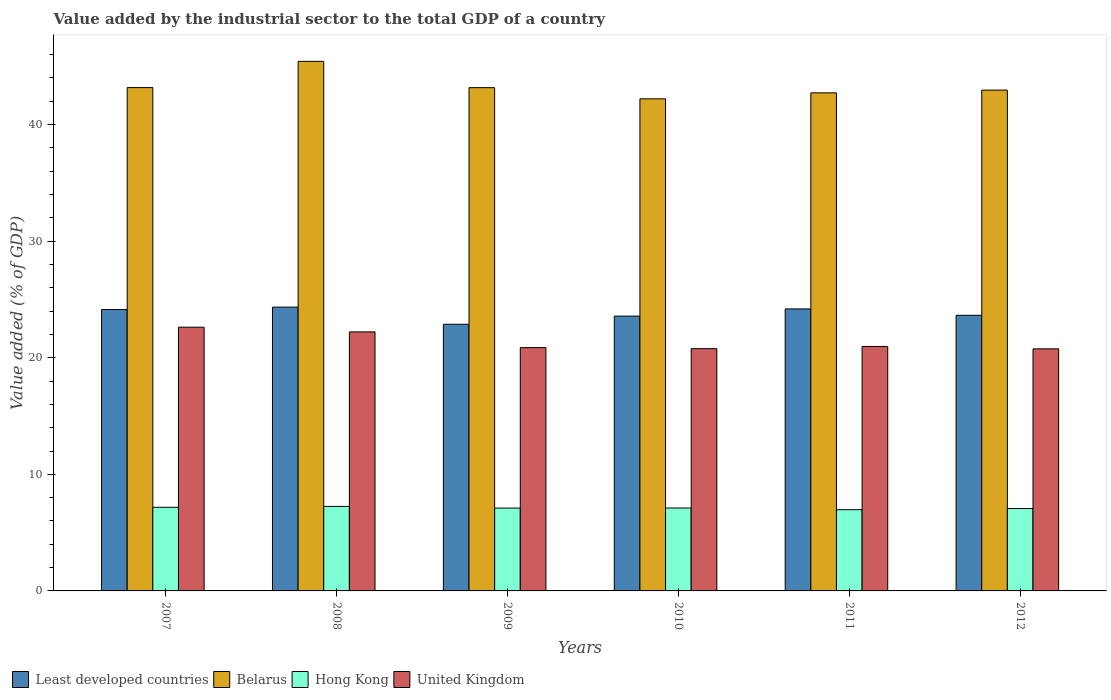Are the number of bars on each tick of the X-axis equal?
Ensure brevity in your answer.  Yes. How many bars are there on the 3rd tick from the left?
Provide a short and direct response. 4. What is the label of the 5th group of bars from the left?
Offer a terse response. 2011. What is the value added by the industrial sector to the total GDP in Belarus in 2011?
Provide a short and direct response. 42.72. Across all years, what is the maximum value added by the industrial sector to the total GDP in Least developed countries?
Your answer should be very brief. 24.34. Across all years, what is the minimum value added by the industrial sector to the total GDP in Least developed countries?
Make the answer very short. 22.87. What is the total value added by the industrial sector to the total GDP in Belarus in the graph?
Offer a terse response. 259.62. What is the difference between the value added by the industrial sector to the total GDP in Least developed countries in 2007 and that in 2008?
Offer a very short reply. -0.2. What is the difference between the value added by the industrial sector to the total GDP in Hong Kong in 2011 and the value added by the industrial sector to the total GDP in Least developed countries in 2012?
Provide a succinct answer. -16.67. What is the average value added by the industrial sector to the total GDP in United Kingdom per year?
Offer a terse response. 21.37. In the year 2008, what is the difference between the value added by the industrial sector to the total GDP in Hong Kong and value added by the industrial sector to the total GDP in Belarus?
Offer a terse response. -38.17. In how many years, is the value added by the industrial sector to the total GDP in Hong Kong greater than 14 %?
Provide a succinct answer. 0. What is the ratio of the value added by the industrial sector to the total GDP in United Kingdom in 2008 to that in 2011?
Provide a short and direct response. 1.06. Is the value added by the industrial sector to the total GDP in Belarus in 2007 less than that in 2011?
Make the answer very short. No. Is the difference between the value added by the industrial sector to the total GDP in Hong Kong in 2008 and 2010 greater than the difference between the value added by the industrial sector to the total GDP in Belarus in 2008 and 2010?
Give a very brief answer. No. What is the difference between the highest and the second highest value added by the industrial sector to the total GDP in Least developed countries?
Give a very brief answer. 0.15. What is the difference between the highest and the lowest value added by the industrial sector to the total GDP in United Kingdom?
Your answer should be compact. 1.86. Is it the case that in every year, the sum of the value added by the industrial sector to the total GDP in Belarus and value added by the industrial sector to the total GDP in Hong Kong is greater than the sum of value added by the industrial sector to the total GDP in United Kingdom and value added by the industrial sector to the total GDP in Least developed countries?
Your answer should be very brief. No. What does the 3rd bar from the right in 2008 represents?
Offer a terse response. Belarus. Is it the case that in every year, the sum of the value added by the industrial sector to the total GDP in United Kingdom and value added by the industrial sector to the total GDP in Belarus is greater than the value added by the industrial sector to the total GDP in Least developed countries?
Your response must be concise. Yes. How many bars are there?
Offer a terse response. 24. How many years are there in the graph?
Ensure brevity in your answer.  6. What is the difference between two consecutive major ticks on the Y-axis?
Keep it short and to the point. 10. Are the values on the major ticks of Y-axis written in scientific E-notation?
Provide a short and direct response. No. Does the graph contain grids?
Your answer should be compact. No. How are the legend labels stacked?
Your response must be concise. Horizontal. What is the title of the graph?
Your response must be concise. Value added by the industrial sector to the total GDP of a country. Does "Libya" appear as one of the legend labels in the graph?
Provide a short and direct response. No. What is the label or title of the Y-axis?
Your answer should be compact. Value added (% of GDP). What is the Value added (% of GDP) in Least developed countries in 2007?
Give a very brief answer. 24.14. What is the Value added (% of GDP) of Belarus in 2007?
Your answer should be very brief. 43.17. What is the Value added (% of GDP) in Hong Kong in 2007?
Ensure brevity in your answer.  7.17. What is the Value added (% of GDP) in United Kingdom in 2007?
Your answer should be compact. 22.62. What is the Value added (% of GDP) in Least developed countries in 2008?
Give a very brief answer. 24.34. What is the Value added (% of GDP) of Belarus in 2008?
Ensure brevity in your answer.  45.42. What is the Value added (% of GDP) in Hong Kong in 2008?
Give a very brief answer. 7.25. What is the Value added (% of GDP) in United Kingdom in 2008?
Keep it short and to the point. 22.22. What is the Value added (% of GDP) in Least developed countries in 2009?
Offer a terse response. 22.87. What is the Value added (% of GDP) of Belarus in 2009?
Offer a very short reply. 43.16. What is the Value added (% of GDP) of Hong Kong in 2009?
Give a very brief answer. 7.11. What is the Value added (% of GDP) of United Kingdom in 2009?
Make the answer very short. 20.87. What is the Value added (% of GDP) of Least developed countries in 2010?
Offer a very short reply. 23.57. What is the Value added (% of GDP) of Belarus in 2010?
Give a very brief answer. 42.21. What is the Value added (% of GDP) in Hong Kong in 2010?
Keep it short and to the point. 7.11. What is the Value added (% of GDP) in United Kingdom in 2010?
Offer a terse response. 20.78. What is the Value added (% of GDP) in Least developed countries in 2011?
Provide a succinct answer. 24.18. What is the Value added (% of GDP) of Belarus in 2011?
Keep it short and to the point. 42.72. What is the Value added (% of GDP) of Hong Kong in 2011?
Your answer should be compact. 6.97. What is the Value added (% of GDP) in United Kingdom in 2011?
Offer a terse response. 20.97. What is the Value added (% of GDP) of Least developed countries in 2012?
Your answer should be compact. 23.64. What is the Value added (% of GDP) of Belarus in 2012?
Give a very brief answer. 42.95. What is the Value added (% of GDP) in Hong Kong in 2012?
Provide a short and direct response. 7.07. What is the Value added (% of GDP) in United Kingdom in 2012?
Your answer should be compact. 20.76. Across all years, what is the maximum Value added (% of GDP) of Least developed countries?
Your response must be concise. 24.34. Across all years, what is the maximum Value added (% of GDP) in Belarus?
Keep it short and to the point. 45.42. Across all years, what is the maximum Value added (% of GDP) in Hong Kong?
Ensure brevity in your answer.  7.25. Across all years, what is the maximum Value added (% of GDP) of United Kingdom?
Ensure brevity in your answer.  22.62. Across all years, what is the minimum Value added (% of GDP) of Least developed countries?
Give a very brief answer. 22.87. Across all years, what is the minimum Value added (% of GDP) in Belarus?
Keep it short and to the point. 42.21. Across all years, what is the minimum Value added (% of GDP) of Hong Kong?
Give a very brief answer. 6.97. Across all years, what is the minimum Value added (% of GDP) in United Kingdom?
Your answer should be compact. 20.76. What is the total Value added (% of GDP) in Least developed countries in the graph?
Make the answer very short. 142.74. What is the total Value added (% of GDP) in Belarus in the graph?
Your answer should be compact. 259.62. What is the total Value added (% of GDP) of Hong Kong in the graph?
Your answer should be compact. 42.67. What is the total Value added (% of GDP) of United Kingdom in the graph?
Your answer should be compact. 128.21. What is the difference between the Value added (% of GDP) of Least developed countries in 2007 and that in 2008?
Give a very brief answer. -0.2. What is the difference between the Value added (% of GDP) of Belarus in 2007 and that in 2008?
Your answer should be compact. -2.25. What is the difference between the Value added (% of GDP) in Hong Kong in 2007 and that in 2008?
Your response must be concise. -0.08. What is the difference between the Value added (% of GDP) of United Kingdom in 2007 and that in 2008?
Your answer should be very brief. 0.4. What is the difference between the Value added (% of GDP) of Least developed countries in 2007 and that in 2009?
Your response must be concise. 1.27. What is the difference between the Value added (% of GDP) of Belarus in 2007 and that in 2009?
Provide a succinct answer. 0.01. What is the difference between the Value added (% of GDP) of Hong Kong in 2007 and that in 2009?
Make the answer very short. 0.07. What is the difference between the Value added (% of GDP) of United Kingdom in 2007 and that in 2009?
Offer a terse response. 1.75. What is the difference between the Value added (% of GDP) in Least developed countries in 2007 and that in 2010?
Offer a terse response. 0.57. What is the difference between the Value added (% of GDP) of Belarus in 2007 and that in 2010?
Offer a very short reply. 0.96. What is the difference between the Value added (% of GDP) in Hong Kong in 2007 and that in 2010?
Your response must be concise. 0.06. What is the difference between the Value added (% of GDP) of United Kingdom in 2007 and that in 2010?
Offer a very short reply. 1.84. What is the difference between the Value added (% of GDP) of Least developed countries in 2007 and that in 2011?
Provide a short and direct response. -0.05. What is the difference between the Value added (% of GDP) in Belarus in 2007 and that in 2011?
Keep it short and to the point. 0.45. What is the difference between the Value added (% of GDP) of Hong Kong in 2007 and that in 2011?
Offer a very short reply. 0.2. What is the difference between the Value added (% of GDP) in United Kingdom in 2007 and that in 2011?
Keep it short and to the point. 1.65. What is the difference between the Value added (% of GDP) in Least developed countries in 2007 and that in 2012?
Provide a succinct answer. 0.5. What is the difference between the Value added (% of GDP) of Belarus in 2007 and that in 2012?
Offer a very short reply. 0.22. What is the difference between the Value added (% of GDP) in Hong Kong in 2007 and that in 2012?
Offer a terse response. 0.11. What is the difference between the Value added (% of GDP) in United Kingdom in 2007 and that in 2012?
Keep it short and to the point. 1.86. What is the difference between the Value added (% of GDP) of Least developed countries in 2008 and that in 2009?
Offer a very short reply. 1.47. What is the difference between the Value added (% of GDP) in Belarus in 2008 and that in 2009?
Make the answer very short. 2.26. What is the difference between the Value added (% of GDP) of Hong Kong in 2008 and that in 2009?
Keep it short and to the point. 0.14. What is the difference between the Value added (% of GDP) in United Kingdom in 2008 and that in 2009?
Provide a succinct answer. 1.35. What is the difference between the Value added (% of GDP) in Least developed countries in 2008 and that in 2010?
Your answer should be compact. 0.77. What is the difference between the Value added (% of GDP) of Belarus in 2008 and that in 2010?
Ensure brevity in your answer.  3.21. What is the difference between the Value added (% of GDP) of Hong Kong in 2008 and that in 2010?
Give a very brief answer. 0.14. What is the difference between the Value added (% of GDP) of United Kingdom in 2008 and that in 2010?
Offer a very short reply. 1.44. What is the difference between the Value added (% of GDP) in Least developed countries in 2008 and that in 2011?
Provide a short and direct response. 0.15. What is the difference between the Value added (% of GDP) in Belarus in 2008 and that in 2011?
Make the answer very short. 2.7. What is the difference between the Value added (% of GDP) of Hong Kong in 2008 and that in 2011?
Provide a succinct answer. 0.28. What is the difference between the Value added (% of GDP) in United Kingdom in 2008 and that in 2011?
Your answer should be very brief. 1.25. What is the difference between the Value added (% of GDP) of Least developed countries in 2008 and that in 2012?
Provide a succinct answer. 0.7. What is the difference between the Value added (% of GDP) of Belarus in 2008 and that in 2012?
Provide a succinct answer. 2.47. What is the difference between the Value added (% of GDP) of Hong Kong in 2008 and that in 2012?
Provide a short and direct response. 0.18. What is the difference between the Value added (% of GDP) in United Kingdom in 2008 and that in 2012?
Provide a succinct answer. 1.45. What is the difference between the Value added (% of GDP) in Least developed countries in 2009 and that in 2010?
Your answer should be very brief. -0.7. What is the difference between the Value added (% of GDP) in Belarus in 2009 and that in 2010?
Offer a terse response. 0.96. What is the difference between the Value added (% of GDP) of Hong Kong in 2009 and that in 2010?
Make the answer very short. -0.01. What is the difference between the Value added (% of GDP) in United Kingdom in 2009 and that in 2010?
Give a very brief answer. 0.09. What is the difference between the Value added (% of GDP) of Least developed countries in 2009 and that in 2011?
Make the answer very short. -1.31. What is the difference between the Value added (% of GDP) in Belarus in 2009 and that in 2011?
Your answer should be compact. 0.44. What is the difference between the Value added (% of GDP) in Hong Kong in 2009 and that in 2011?
Offer a terse response. 0.14. What is the difference between the Value added (% of GDP) of United Kingdom in 2009 and that in 2011?
Your answer should be compact. -0.1. What is the difference between the Value added (% of GDP) of Least developed countries in 2009 and that in 2012?
Ensure brevity in your answer.  -0.77. What is the difference between the Value added (% of GDP) of Belarus in 2009 and that in 2012?
Give a very brief answer. 0.21. What is the difference between the Value added (% of GDP) in Hong Kong in 2009 and that in 2012?
Your answer should be very brief. 0.04. What is the difference between the Value added (% of GDP) in United Kingdom in 2009 and that in 2012?
Your answer should be very brief. 0.11. What is the difference between the Value added (% of GDP) in Least developed countries in 2010 and that in 2011?
Give a very brief answer. -0.61. What is the difference between the Value added (% of GDP) in Belarus in 2010 and that in 2011?
Keep it short and to the point. -0.51. What is the difference between the Value added (% of GDP) in Hong Kong in 2010 and that in 2011?
Give a very brief answer. 0.14. What is the difference between the Value added (% of GDP) in United Kingdom in 2010 and that in 2011?
Ensure brevity in your answer.  -0.19. What is the difference between the Value added (% of GDP) of Least developed countries in 2010 and that in 2012?
Offer a terse response. -0.07. What is the difference between the Value added (% of GDP) in Belarus in 2010 and that in 2012?
Keep it short and to the point. -0.75. What is the difference between the Value added (% of GDP) in Hong Kong in 2010 and that in 2012?
Provide a succinct answer. 0.05. What is the difference between the Value added (% of GDP) in United Kingdom in 2010 and that in 2012?
Give a very brief answer. 0.02. What is the difference between the Value added (% of GDP) in Least developed countries in 2011 and that in 2012?
Make the answer very short. 0.54. What is the difference between the Value added (% of GDP) of Belarus in 2011 and that in 2012?
Offer a very short reply. -0.23. What is the difference between the Value added (% of GDP) in Hong Kong in 2011 and that in 2012?
Keep it short and to the point. -0.1. What is the difference between the Value added (% of GDP) in United Kingdom in 2011 and that in 2012?
Your answer should be compact. 0.21. What is the difference between the Value added (% of GDP) of Least developed countries in 2007 and the Value added (% of GDP) of Belarus in 2008?
Your answer should be compact. -21.28. What is the difference between the Value added (% of GDP) of Least developed countries in 2007 and the Value added (% of GDP) of Hong Kong in 2008?
Keep it short and to the point. 16.89. What is the difference between the Value added (% of GDP) in Least developed countries in 2007 and the Value added (% of GDP) in United Kingdom in 2008?
Ensure brevity in your answer.  1.92. What is the difference between the Value added (% of GDP) of Belarus in 2007 and the Value added (% of GDP) of Hong Kong in 2008?
Your answer should be compact. 35.92. What is the difference between the Value added (% of GDP) of Belarus in 2007 and the Value added (% of GDP) of United Kingdom in 2008?
Your answer should be very brief. 20.95. What is the difference between the Value added (% of GDP) in Hong Kong in 2007 and the Value added (% of GDP) in United Kingdom in 2008?
Provide a short and direct response. -15.04. What is the difference between the Value added (% of GDP) of Least developed countries in 2007 and the Value added (% of GDP) of Belarus in 2009?
Offer a very short reply. -19.03. What is the difference between the Value added (% of GDP) in Least developed countries in 2007 and the Value added (% of GDP) in Hong Kong in 2009?
Offer a very short reply. 17.03. What is the difference between the Value added (% of GDP) of Least developed countries in 2007 and the Value added (% of GDP) of United Kingdom in 2009?
Keep it short and to the point. 3.27. What is the difference between the Value added (% of GDP) in Belarus in 2007 and the Value added (% of GDP) in Hong Kong in 2009?
Provide a succinct answer. 36.06. What is the difference between the Value added (% of GDP) of Belarus in 2007 and the Value added (% of GDP) of United Kingdom in 2009?
Keep it short and to the point. 22.3. What is the difference between the Value added (% of GDP) of Hong Kong in 2007 and the Value added (% of GDP) of United Kingdom in 2009?
Ensure brevity in your answer.  -13.69. What is the difference between the Value added (% of GDP) in Least developed countries in 2007 and the Value added (% of GDP) in Belarus in 2010?
Your response must be concise. -18.07. What is the difference between the Value added (% of GDP) of Least developed countries in 2007 and the Value added (% of GDP) of Hong Kong in 2010?
Ensure brevity in your answer.  17.02. What is the difference between the Value added (% of GDP) in Least developed countries in 2007 and the Value added (% of GDP) in United Kingdom in 2010?
Make the answer very short. 3.36. What is the difference between the Value added (% of GDP) of Belarus in 2007 and the Value added (% of GDP) of Hong Kong in 2010?
Your response must be concise. 36.06. What is the difference between the Value added (% of GDP) in Belarus in 2007 and the Value added (% of GDP) in United Kingdom in 2010?
Provide a succinct answer. 22.39. What is the difference between the Value added (% of GDP) of Hong Kong in 2007 and the Value added (% of GDP) of United Kingdom in 2010?
Keep it short and to the point. -13.61. What is the difference between the Value added (% of GDP) in Least developed countries in 2007 and the Value added (% of GDP) in Belarus in 2011?
Your response must be concise. -18.58. What is the difference between the Value added (% of GDP) of Least developed countries in 2007 and the Value added (% of GDP) of Hong Kong in 2011?
Your answer should be compact. 17.17. What is the difference between the Value added (% of GDP) of Least developed countries in 2007 and the Value added (% of GDP) of United Kingdom in 2011?
Your answer should be very brief. 3.17. What is the difference between the Value added (% of GDP) of Belarus in 2007 and the Value added (% of GDP) of Hong Kong in 2011?
Provide a succinct answer. 36.2. What is the difference between the Value added (% of GDP) in Belarus in 2007 and the Value added (% of GDP) in United Kingdom in 2011?
Provide a succinct answer. 22.2. What is the difference between the Value added (% of GDP) of Hong Kong in 2007 and the Value added (% of GDP) of United Kingdom in 2011?
Provide a short and direct response. -13.8. What is the difference between the Value added (% of GDP) of Least developed countries in 2007 and the Value added (% of GDP) of Belarus in 2012?
Keep it short and to the point. -18.82. What is the difference between the Value added (% of GDP) of Least developed countries in 2007 and the Value added (% of GDP) of Hong Kong in 2012?
Provide a succinct answer. 17.07. What is the difference between the Value added (% of GDP) of Least developed countries in 2007 and the Value added (% of GDP) of United Kingdom in 2012?
Your response must be concise. 3.37. What is the difference between the Value added (% of GDP) in Belarus in 2007 and the Value added (% of GDP) in Hong Kong in 2012?
Ensure brevity in your answer.  36.1. What is the difference between the Value added (% of GDP) of Belarus in 2007 and the Value added (% of GDP) of United Kingdom in 2012?
Your response must be concise. 22.41. What is the difference between the Value added (% of GDP) in Hong Kong in 2007 and the Value added (% of GDP) in United Kingdom in 2012?
Provide a short and direct response. -13.59. What is the difference between the Value added (% of GDP) of Least developed countries in 2008 and the Value added (% of GDP) of Belarus in 2009?
Ensure brevity in your answer.  -18.82. What is the difference between the Value added (% of GDP) of Least developed countries in 2008 and the Value added (% of GDP) of Hong Kong in 2009?
Make the answer very short. 17.23. What is the difference between the Value added (% of GDP) of Least developed countries in 2008 and the Value added (% of GDP) of United Kingdom in 2009?
Offer a very short reply. 3.47. What is the difference between the Value added (% of GDP) of Belarus in 2008 and the Value added (% of GDP) of Hong Kong in 2009?
Ensure brevity in your answer.  38.31. What is the difference between the Value added (% of GDP) in Belarus in 2008 and the Value added (% of GDP) in United Kingdom in 2009?
Give a very brief answer. 24.55. What is the difference between the Value added (% of GDP) of Hong Kong in 2008 and the Value added (% of GDP) of United Kingdom in 2009?
Your response must be concise. -13.62. What is the difference between the Value added (% of GDP) of Least developed countries in 2008 and the Value added (% of GDP) of Belarus in 2010?
Your answer should be compact. -17.87. What is the difference between the Value added (% of GDP) of Least developed countries in 2008 and the Value added (% of GDP) of Hong Kong in 2010?
Provide a succinct answer. 17.23. What is the difference between the Value added (% of GDP) in Least developed countries in 2008 and the Value added (% of GDP) in United Kingdom in 2010?
Provide a succinct answer. 3.56. What is the difference between the Value added (% of GDP) of Belarus in 2008 and the Value added (% of GDP) of Hong Kong in 2010?
Make the answer very short. 38.31. What is the difference between the Value added (% of GDP) of Belarus in 2008 and the Value added (% of GDP) of United Kingdom in 2010?
Give a very brief answer. 24.64. What is the difference between the Value added (% of GDP) in Hong Kong in 2008 and the Value added (% of GDP) in United Kingdom in 2010?
Your response must be concise. -13.53. What is the difference between the Value added (% of GDP) of Least developed countries in 2008 and the Value added (% of GDP) of Belarus in 2011?
Give a very brief answer. -18.38. What is the difference between the Value added (% of GDP) of Least developed countries in 2008 and the Value added (% of GDP) of Hong Kong in 2011?
Provide a short and direct response. 17.37. What is the difference between the Value added (% of GDP) in Least developed countries in 2008 and the Value added (% of GDP) in United Kingdom in 2011?
Give a very brief answer. 3.37. What is the difference between the Value added (% of GDP) in Belarus in 2008 and the Value added (% of GDP) in Hong Kong in 2011?
Ensure brevity in your answer.  38.45. What is the difference between the Value added (% of GDP) of Belarus in 2008 and the Value added (% of GDP) of United Kingdom in 2011?
Keep it short and to the point. 24.45. What is the difference between the Value added (% of GDP) of Hong Kong in 2008 and the Value added (% of GDP) of United Kingdom in 2011?
Give a very brief answer. -13.72. What is the difference between the Value added (% of GDP) of Least developed countries in 2008 and the Value added (% of GDP) of Belarus in 2012?
Offer a very short reply. -18.61. What is the difference between the Value added (% of GDP) of Least developed countries in 2008 and the Value added (% of GDP) of Hong Kong in 2012?
Your answer should be very brief. 17.27. What is the difference between the Value added (% of GDP) in Least developed countries in 2008 and the Value added (% of GDP) in United Kingdom in 2012?
Make the answer very short. 3.58. What is the difference between the Value added (% of GDP) in Belarus in 2008 and the Value added (% of GDP) in Hong Kong in 2012?
Make the answer very short. 38.35. What is the difference between the Value added (% of GDP) of Belarus in 2008 and the Value added (% of GDP) of United Kingdom in 2012?
Keep it short and to the point. 24.66. What is the difference between the Value added (% of GDP) in Hong Kong in 2008 and the Value added (% of GDP) in United Kingdom in 2012?
Provide a succinct answer. -13.51. What is the difference between the Value added (% of GDP) in Least developed countries in 2009 and the Value added (% of GDP) in Belarus in 2010?
Keep it short and to the point. -19.34. What is the difference between the Value added (% of GDP) of Least developed countries in 2009 and the Value added (% of GDP) of Hong Kong in 2010?
Your answer should be very brief. 15.76. What is the difference between the Value added (% of GDP) of Least developed countries in 2009 and the Value added (% of GDP) of United Kingdom in 2010?
Give a very brief answer. 2.09. What is the difference between the Value added (% of GDP) in Belarus in 2009 and the Value added (% of GDP) in Hong Kong in 2010?
Keep it short and to the point. 36.05. What is the difference between the Value added (% of GDP) of Belarus in 2009 and the Value added (% of GDP) of United Kingdom in 2010?
Your answer should be very brief. 22.38. What is the difference between the Value added (% of GDP) of Hong Kong in 2009 and the Value added (% of GDP) of United Kingdom in 2010?
Your answer should be compact. -13.67. What is the difference between the Value added (% of GDP) of Least developed countries in 2009 and the Value added (% of GDP) of Belarus in 2011?
Make the answer very short. -19.85. What is the difference between the Value added (% of GDP) in Least developed countries in 2009 and the Value added (% of GDP) in Hong Kong in 2011?
Your response must be concise. 15.9. What is the difference between the Value added (% of GDP) in Least developed countries in 2009 and the Value added (% of GDP) in United Kingdom in 2011?
Your answer should be compact. 1.9. What is the difference between the Value added (% of GDP) in Belarus in 2009 and the Value added (% of GDP) in Hong Kong in 2011?
Ensure brevity in your answer.  36.19. What is the difference between the Value added (% of GDP) of Belarus in 2009 and the Value added (% of GDP) of United Kingdom in 2011?
Ensure brevity in your answer.  22.19. What is the difference between the Value added (% of GDP) of Hong Kong in 2009 and the Value added (% of GDP) of United Kingdom in 2011?
Make the answer very short. -13.86. What is the difference between the Value added (% of GDP) of Least developed countries in 2009 and the Value added (% of GDP) of Belarus in 2012?
Your answer should be compact. -20.08. What is the difference between the Value added (% of GDP) of Least developed countries in 2009 and the Value added (% of GDP) of Hong Kong in 2012?
Your answer should be compact. 15.8. What is the difference between the Value added (% of GDP) in Least developed countries in 2009 and the Value added (% of GDP) in United Kingdom in 2012?
Keep it short and to the point. 2.11. What is the difference between the Value added (% of GDP) of Belarus in 2009 and the Value added (% of GDP) of Hong Kong in 2012?
Offer a very short reply. 36.1. What is the difference between the Value added (% of GDP) in Belarus in 2009 and the Value added (% of GDP) in United Kingdom in 2012?
Your answer should be very brief. 22.4. What is the difference between the Value added (% of GDP) of Hong Kong in 2009 and the Value added (% of GDP) of United Kingdom in 2012?
Give a very brief answer. -13.66. What is the difference between the Value added (% of GDP) of Least developed countries in 2010 and the Value added (% of GDP) of Belarus in 2011?
Provide a short and direct response. -19.15. What is the difference between the Value added (% of GDP) in Least developed countries in 2010 and the Value added (% of GDP) in Hong Kong in 2011?
Ensure brevity in your answer.  16.6. What is the difference between the Value added (% of GDP) of Least developed countries in 2010 and the Value added (% of GDP) of United Kingdom in 2011?
Your answer should be compact. 2.6. What is the difference between the Value added (% of GDP) of Belarus in 2010 and the Value added (% of GDP) of Hong Kong in 2011?
Offer a very short reply. 35.24. What is the difference between the Value added (% of GDP) of Belarus in 2010 and the Value added (% of GDP) of United Kingdom in 2011?
Ensure brevity in your answer.  21.24. What is the difference between the Value added (% of GDP) in Hong Kong in 2010 and the Value added (% of GDP) in United Kingdom in 2011?
Ensure brevity in your answer.  -13.86. What is the difference between the Value added (% of GDP) of Least developed countries in 2010 and the Value added (% of GDP) of Belarus in 2012?
Give a very brief answer. -19.38. What is the difference between the Value added (% of GDP) in Least developed countries in 2010 and the Value added (% of GDP) in Hong Kong in 2012?
Your answer should be very brief. 16.5. What is the difference between the Value added (% of GDP) in Least developed countries in 2010 and the Value added (% of GDP) in United Kingdom in 2012?
Keep it short and to the point. 2.81. What is the difference between the Value added (% of GDP) in Belarus in 2010 and the Value added (% of GDP) in Hong Kong in 2012?
Keep it short and to the point. 35.14. What is the difference between the Value added (% of GDP) in Belarus in 2010 and the Value added (% of GDP) in United Kingdom in 2012?
Your answer should be very brief. 21.44. What is the difference between the Value added (% of GDP) of Hong Kong in 2010 and the Value added (% of GDP) of United Kingdom in 2012?
Provide a short and direct response. -13.65. What is the difference between the Value added (% of GDP) in Least developed countries in 2011 and the Value added (% of GDP) in Belarus in 2012?
Offer a very short reply. -18.77. What is the difference between the Value added (% of GDP) of Least developed countries in 2011 and the Value added (% of GDP) of Hong Kong in 2012?
Your answer should be very brief. 17.12. What is the difference between the Value added (% of GDP) of Least developed countries in 2011 and the Value added (% of GDP) of United Kingdom in 2012?
Your answer should be compact. 3.42. What is the difference between the Value added (% of GDP) of Belarus in 2011 and the Value added (% of GDP) of Hong Kong in 2012?
Give a very brief answer. 35.65. What is the difference between the Value added (% of GDP) in Belarus in 2011 and the Value added (% of GDP) in United Kingdom in 2012?
Give a very brief answer. 21.96. What is the difference between the Value added (% of GDP) in Hong Kong in 2011 and the Value added (% of GDP) in United Kingdom in 2012?
Provide a succinct answer. -13.79. What is the average Value added (% of GDP) of Least developed countries per year?
Provide a short and direct response. 23.79. What is the average Value added (% of GDP) of Belarus per year?
Ensure brevity in your answer.  43.27. What is the average Value added (% of GDP) in Hong Kong per year?
Provide a short and direct response. 7.11. What is the average Value added (% of GDP) in United Kingdom per year?
Give a very brief answer. 21.37. In the year 2007, what is the difference between the Value added (% of GDP) of Least developed countries and Value added (% of GDP) of Belarus?
Ensure brevity in your answer.  -19.03. In the year 2007, what is the difference between the Value added (% of GDP) in Least developed countries and Value added (% of GDP) in Hong Kong?
Ensure brevity in your answer.  16.96. In the year 2007, what is the difference between the Value added (% of GDP) in Least developed countries and Value added (% of GDP) in United Kingdom?
Offer a very short reply. 1.52. In the year 2007, what is the difference between the Value added (% of GDP) in Belarus and Value added (% of GDP) in Hong Kong?
Offer a terse response. 36. In the year 2007, what is the difference between the Value added (% of GDP) in Belarus and Value added (% of GDP) in United Kingdom?
Offer a very short reply. 20.55. In the year 2007, what is the difference between the Value added (% of GDP) in Hong Kong and Value added (% of GDP) in United Kingdom?
Give a very brief answer. -15.45. In the year 2008, what is the difference between the Value added (% of GDP) of Least developed countries and Value added (% of GDP) of Belarus?
Your response must be concise. -21.08. In the year 2008, what is the difference between the Value added (% of GDP) in Least developed countries and Value added (% of GDP) in Hong Kong?
Provide a succinct answer. 17.09. In the year 2008, what is the difference between the Value added (% of GDP) in Least developed countries and Value added (% of GDP) in United Kingdom?
Make the answer very short. 2.12. In the year 2008, what is the difference between the Value added (% of GDP) in Belarus and Value added (% of GDP) in Hong Kong?
Ensure brevity in your answer.  38.17. In the year 2008, what is the difference between the Value added (% of GDP) in Belarus and Value added (% of GDP) in United Kingdom?
Offer a terse response. 23.2. In the year 2008, what is the difference between the Value added (% of GDP) of Hong Kong and Value added (% of GDP) of United Kingdom?
Offer a very short reply. -14.97. In the year 2009, what is the difference between the Value added (% of GDP) in Least developed countries and Value added (% of GDP) in Belarus?
Make the answer very short. -20.29. In the year 2009, what is the difference between the Value added (% of GDP) of Least developed countries and Value added (% of GDP) of Hong Kong?
Give a very brief answer. 15.76. In the year 2009, what is the difference between the Value added (% of GDP) in Least developed countries and Value added (% of GDP) in United Kingdom?
Your answer should be very brief. 2. In the year 2009, what is the difference between the Value added (% of GDP) in Belarus and Value added (% of GDP) in Hong Kong?
Provide a short and direct response. 36.06. In the year 2009, what is the difference between the Value added (% of GDP) of Belarus and Value added (% of GDP) of United Kingdom?
Ensure brevity in your answer.  22.3. In the year 2009, what is the difference between the Value added (% of GDP) in Hong Kong and Value added (% of GDP) in United Kingdom?
Offer a terse response. -13.76. In the year 2010, what is the difference between the Value added (% of GDP) in Least developed countries and Value added (% of GDP) in Belarus?
Provide a succinct answer. -18.64. In the year 2010, what is the difference between the Value added (% of GDP) in Least developed countries and Value added (% of GDP) in Hong Kong?
Offer a terse response. 16.46. In the year 2010, what is the difference between the Value added (% of GDP) of Least developed countries and Value added (% of GDP) of United Kingdom?
Keep it short and to the point. 2.79. In the year 2010, what is the difference between the Value added (% of GDP) of Belarus and Value added (% of GDP) of Hong Kong?
Keep it short and to the point. 35.09. In the year 2010, what is the difference between the Value added (% of GDP) of Belarus and Value added (% of GDP) of United Kingdom?
Keep it short and to the point. 21.43. In the year 2010, what is the difference between the Value added (% of GDP) in Hong Kong and Value added (% of GDP) in United Kingdom?
Your response must be concise. -13.67. In the year 2011, what is the difference between the Value added (% of GDP) of Least developed countries and Value added (% of GDP) of Belarus?
Your answer should be compact. -18.53. In the year 2011, what is the difference between the Value added (% of GDP) of Least developed countries and Value added (% of GDP) of Hong Kong?
Offer a very short reply. 17.22. In the year 2011, what is the difference between the Value added (% of GDP) in Least developed countries and Value added (% of GDP) in United Kingdom?
Provide a short and direct response. 3.22. In the year 2011, what is the difference between the Value added (% of GDP) in Belarus and Value added (% of GDP) in Hong Kong?
Your answer should be compact. 35.75. In the year 2011, what is the difference between the Value added (% of GDP) in Belarus and Value added (% of GDP) in United Kingdom?
Provide a short and direct response. 21.75. In the year 2011, what is the difference between the Value added (% of GDP) of Hong Kong and Value added (% of GDP) of United Kingdom?
Your answer should be very brief. -14. In the year 2012, what is the difference between the Value added (% of GDP) of Least developed countries and Value added (% of GDP) of Belarus?
Ensure brevity in your answer.  -19.31. In the year 2012, what is the difference between the Value added (% of GDP) in Least developed countries and Value added (% of GDP) in Hong Kong?
Offer a very short reply. 16.57. In the year 2012, what is the difference between the Value added (% of GDP) of Least developed countries and Value added (% of GDP) of United Kingdom?
Provide a short and direct response. 2.88. In the year 2012, what is the difference between the Value added (% of GDP) in Belarus and Value added (% of GDP) in Hong Kong?
Give a very brief answer. 35.89. In the year 2012, what is the difference between the Value added (% of GDP) in Belarus and Value added (% of GDP) in United Kingdom?
Your answer should be compact. 22.19. In the year 2012, what is the difference between the Value added (% of GDP) in Hong Kong and Value added (% of GDP) in United Kingdom?
Provide a short and direct response. -13.7. What is the ratio of the Value added (% of GDP) in Least developed countries in 2007 to that in 2008?
Offer a very short reply. 0.99. What is the ratio of the Value added (% of GDP) of Belarus in 2007 to that in 2008?
Provide a succinct answer. 0.95. What is the ratio of the Value added (% of GDP) of Hong Kong in 2007 to that in 2008?
Provide a succinct answer. 0.99. What is the ratio of the Value added (% of GDP) in United Kingdom in 2007 to that in 2008?
Provide a succinct answer. 1.02. What is the ratio of the Value added (% of GDP) of Least developed countries in 2007 to that in 2009?
Provide a succinct answer. 1.06. What is the ratio of the Value added (% of GDP) of Hong Kong in 2007 to that in 2009?
Provide a succinct answer. 1.01. What is the ratio of the Value added (% of GDP) of United Kingdom in 2007 to that in 2009?
Provide a succinct answer. 1.08. What is the ratio of the Value added (% of GDP) in Least developed countries in 2007 to that in 2010?
Provide a short and direct response. 1.02. What is the ratio of the Value added (% of GDP) in Belarus in 2007 to that in 2010?
Offer a terse response. 1.02. What is the ratio of the Value added (% of GDP) of Hong Kong in 2007 to that in 2010?
Make the answer very short. 1.01. What is the ratio of the Value added (% of GDP) of United Kingdom in 2007 to that in 2010?
Your answer should be very brief. 1.09. What is the ratio of the Value added (% of GDP) of Belarus in 2007 to that in 2011?
Offer a very short reply. 1.01. What is the ratio of the Value added (% of GDP) in Hong Kong in 2007 to that in 2011?
Offer a terse response. 1.03. What is the ratio of the Value added (% of GDP) of United Kingdom in 2007 to that in 2011?
Offer a very short reply. 1.08. What is the ratio of the Value added (% of GDP) in Least developed countries in 2007 to that in 2012?
Provide a succinct answer. 1.02. What is the ratio of the Value added (% of GDP) in Belarus in 2007 to that in 2012?
Your response must be concise. 1. What is the ratio of the Value added (% of GDP) of Hong Kong in 2007 to that in 2012?
Give a very brief answer. 1.02. What is the ratio of the Value added (% of GDP) of United Kingdom in 2007 to that in 2012?
Your answer should be very brief. 1.09. What is the ratio of the Value added (% of GDP) in Least developed countries in 2008 to that in 2009?
Keep it short and to the point. 1.06. What is the ratio of the Value added (% of GDP) of Belarus in 2008 to that in 2009?
Give a very brief answer. 1.05. What is the ratio of the Value added (% of GDP) of Hong Kong in 2008 to that in 2009?
Your answer should be compact. 1.02. What is the ratio of the Value added (% of GDP) of United Kingdom in 2008 to that in 2009?
Ensure brevity in your answer.  1.06. What is the ratio of the Value added (% of GDP) in Least developed countries in 2008 to that in 2010?
Provide a succinct answer. 1.03. What is the ratio of the Value added (% of GDP) of Belarus in 2008 to that in 2010?
Ensure brevity in your answer.  1.08. What is the ratio of the Value added (% of GDP) of Hong Kong in 2008 to that in 2010?
Your answer should be very brief. 1.02. What is the ratio of the Value added (% of GDP) in United Kingdom in 2008 to that in 2010?
Provide a succinct answer. 1.07. What is the ratio of the Value added (% of GDP) of Least developed countries in 2008 to that in 2011?
Provide a succinct answer. 1.01. What is the ratio of the Value added (% of GDP) of Belarus in 2008 to that in 2011?
Make the answer very short. 1.06. What is the ratio of the Value added (% of GDP) in Hong Kong in 2008 to that in 2011?
Your answer should be compact. 1.04. What is the ratio of the Value added (% of GDP) in United Kingdom in 2008 to that in 2011?
Your answer should be compact. 1.06. What is the ratio of the Value added (% of GDP) in Least developed countries in 2008 to that in 2012?
Provide a succinct answer. 1.03. What is the ratio of the Value added (% of GDP) in Belarus in 2008 to that in 2012?
Your response must be concise. 1.06. What is the ratio of the Value added (% of GDP) in Hong Kong in 2008 to that in 2012?
Your response must be concise. 1.03. What is the ratio of the Value added (% of GDP) of United Kingdom in 2008 to that in 2012?
Your answer should be compact. 1.07. What is the ratio of the Value added (% of GDP) of Least developed countries in 2009 to that in 2010?
Your response must be concise. 0.97. What is the ratio of the Value added (% of GDP) in Belarus in 2009 to that in 2010?
Provide a succinct answer. 1.02. What is the ratio of the Value added (% of GDP) in Hong Kong in 2009 to that in 2010?
Your response must be concise. 1. What is the ratio of the Value added (% of GDP) in United Kingdom in 2009 to that in 2010?
Make the answer very short. 1. What is the ratio of the Value added (% of GDP) of Least developed countries in 2009 to that in 2011?
Keep it short and to the point. 0.95. What is the ratio of the Value added (% of GDP) in Belarus in 2009 to that in 2011?
Make the answer very short. 1.01. What is the ratio of the Value added (% of GDP) in Hong Kong in 2009 to that in 2011?
Your answer should be compact. 1.02. What is the ratio of the Value added (% of GDP) in United Kingdom in 2009 to that in 2011?
Offer a terse response. 1. What is the ratio of the Value added (% of GDP) in Least developed countries in 2009 to that in 2012?
Ensure brevity in your answer.  0.97. What is the ratio of the Value added (% of GDP) in Least developed countries in 2010 to that in 2011?
Keep it short and to the point. 0.97. What is the ratio of the Value added (% of GDP) in Belarus in 2010 to that in 2011?
Make the answer very short. 0.99. What is the ratio of the Value added (% of GDP) in Hong Kong in 2010 to that in 2011?
Offer a very short reply. 1.02. What is the ratio of the Value added (% of GDP) of United Kingdom in 2010 to that in 2011?
Offer a very short reply. 0.99. What is the ratio of the Value added (% of GDP) of Least developed countries in 2010 to that in 2012?
Your answer should be very brief. 1. What is the ratio of the Value added (% of GDP) in Belarus in 2010 to that in 2012?
Your answer should be very brief. 0.98. What is the ratio of the Value added (% of GDP) of United Kingdom in 2010 to that in 2012?
Provide a succinct answer. 1. What is the ratio of the Value added (% of GDP) in Hong Kong in 2011 to that in 2012?
Keep it short and to the point. 0.99. What is the ratio of the Value added (% of GDP) of United Kingdom in 2011 to that in 2012?
Keep it short and to the point. 1.01. What is the difference between the highest and the second highest Value added (% of GDP) of Least developed countries?
Offer a very short reply. 0.15. What is the difference between the highest and the second highest Value added (% of GDP) in Belarus?
Provide a succinct answer. 2.25. What is the difference between the highest and the second highest Value added (% of GDP) of Hong Kong?
Provide a succinct answer. 0.08. What is the difference between the highest and the second highest Value added (% of GDP) in United Kingdom?
Make the answer very short. 0.4. What is the difference between the highest and the lowest Value added (% of GDP) in Least developed countries?
Ensure brevity in your answer.  1.47. What is the difference between the highest and the lowest Value added (% of GDP) of Belarus?
Provide a short and direct response. 3.21. What is the difference between the highest and the lowest Value added (% of GDP) of Hong Kong?
Give a very brief answer. 0.28. What is the difference between the highest and the lowest Value added (% of GDP) in United Kingdom?
Provide a succinct answer. 1.86. 